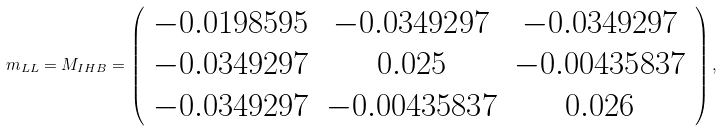Convert formula to latex. <formula><loc_0><loc_0><loc_500><loc_500>m _ { L L } = M _ { I H B } = \left ( \begin{array} { c c c } - 0 . 0 1 9 8 5 9 5 & - 0 . 0 3 4 9 2 9 7 & - 0 . 0 3 4 9 2 9 7 \\ - 0 . 0 3 4 9 2 9 7 & 0 . 0 2 5 & - 0 . 0 0 4 3 5 8 3 7 \\ - 0 . 0 3 4 9 2 9 7 & - 0 . 0 0 4 3 5 8 3 7 & 0 . 0 2 6 \end{array} \right ) ,</formula> 